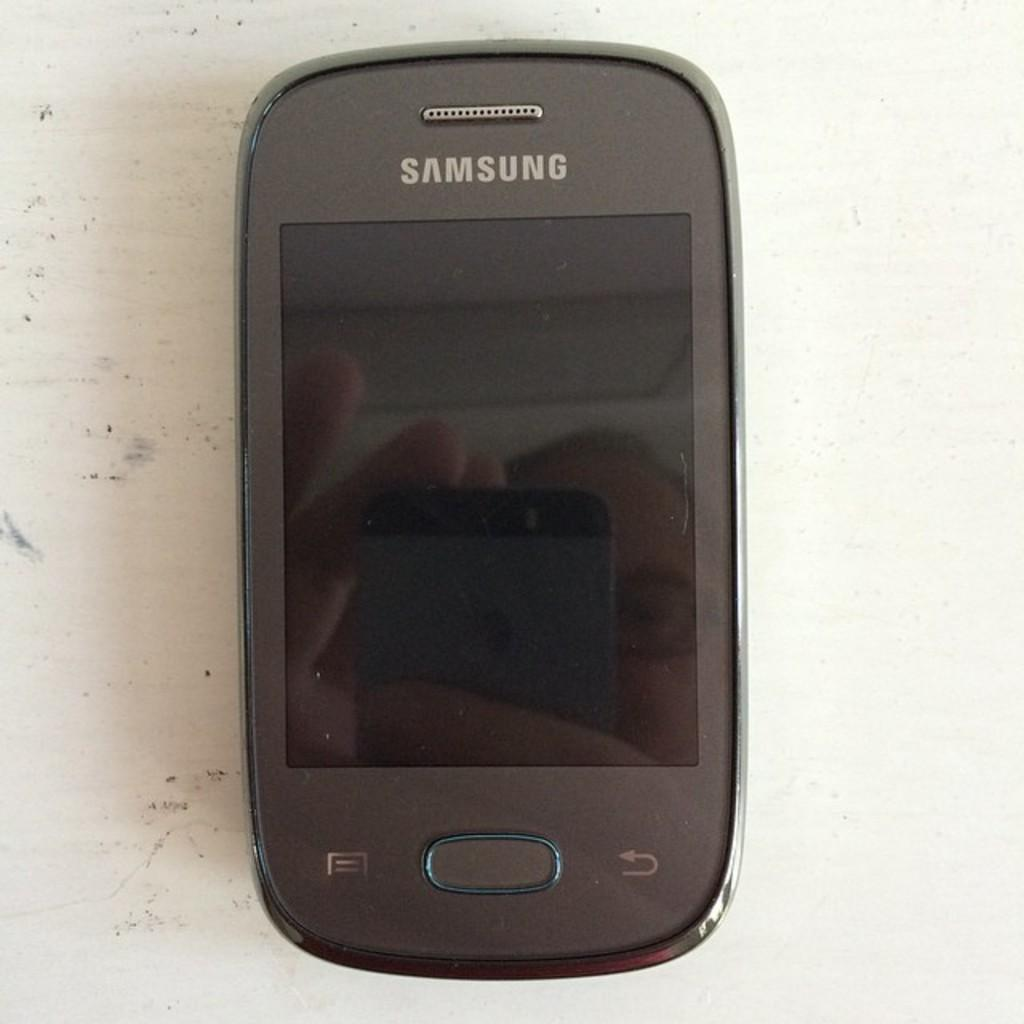<image>
Write a terse but informative summary of the picture. A grey colored Samsung phone with a person reflection in the screen. 